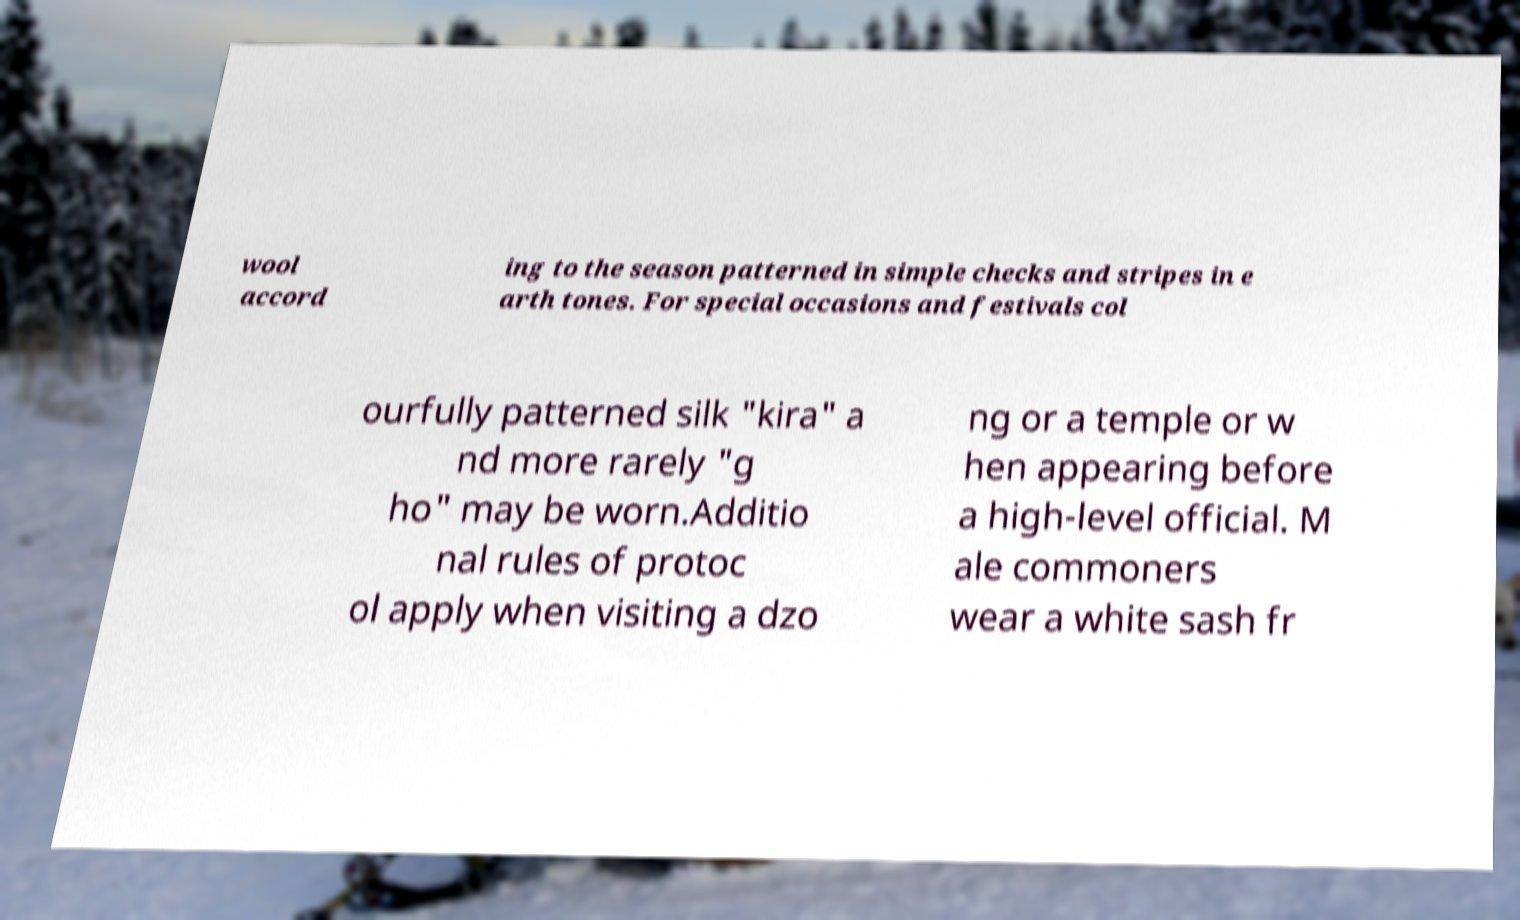I need the written content from this picture converted into text. Can you do that? wool accord ing to the season patterned in simple checks and stripes in e arth tones. For special occasions and festivals col ourfully patterned silk "kira" a nd more rarely "g ho" may be worn.Additio nal rules of protoc ol apply when visiting a dzo ng or a temple or w hen appearing before a high-level official. M ale commoners wear a white sash fr 